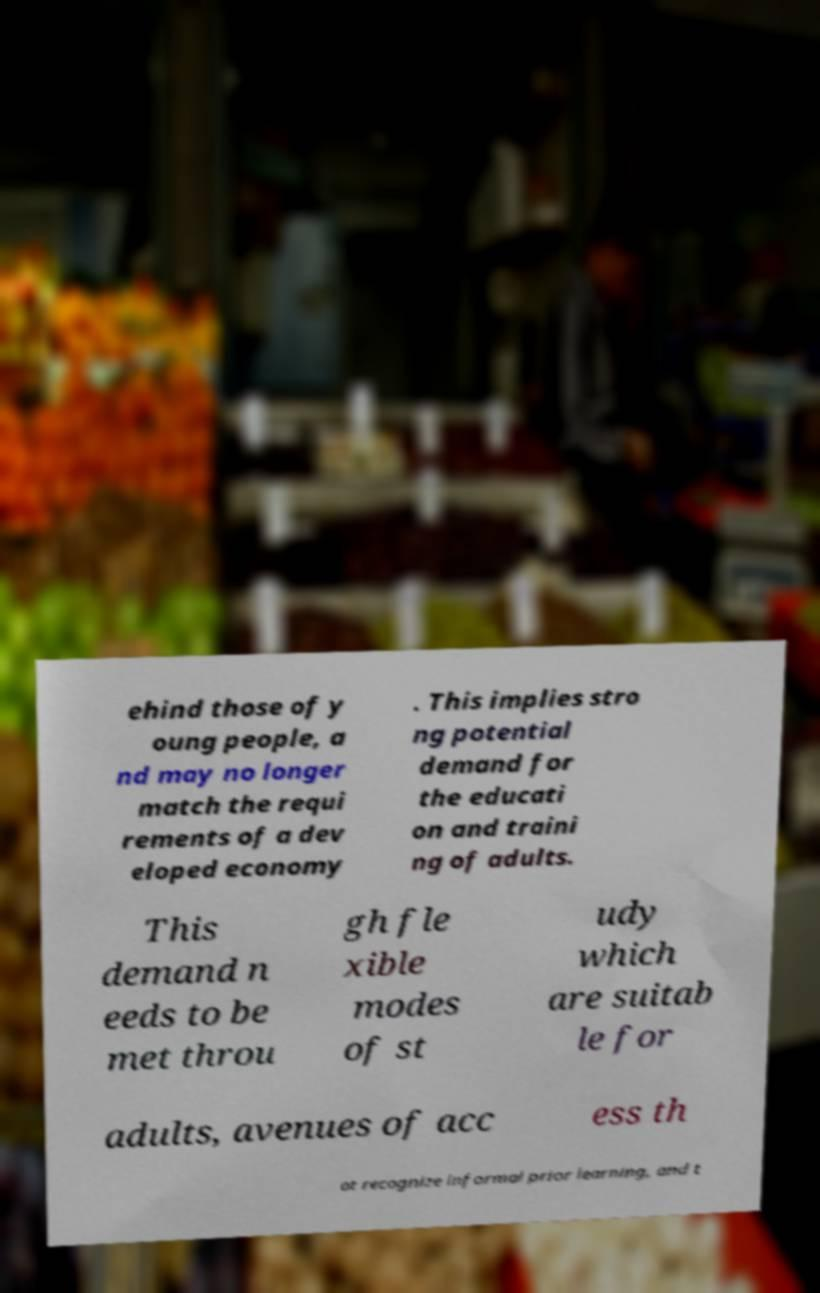Could you assist in decoding the text presented in this image and type it out clearly? ehind those of y oung people, a nd may no longer match the requi rements of a dev eloped economy . This implies stro ng potential demand for the educati on and traini ng of adults. This demand n eeds to be met throu gh fle xible modes of st udy which are suitab le for adults, avenues of acc ess th at recognize informal prior learning, and t 